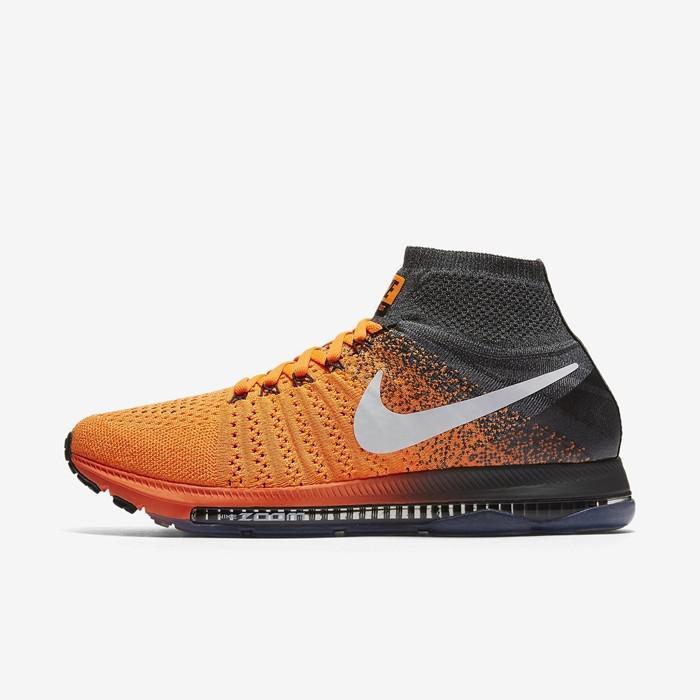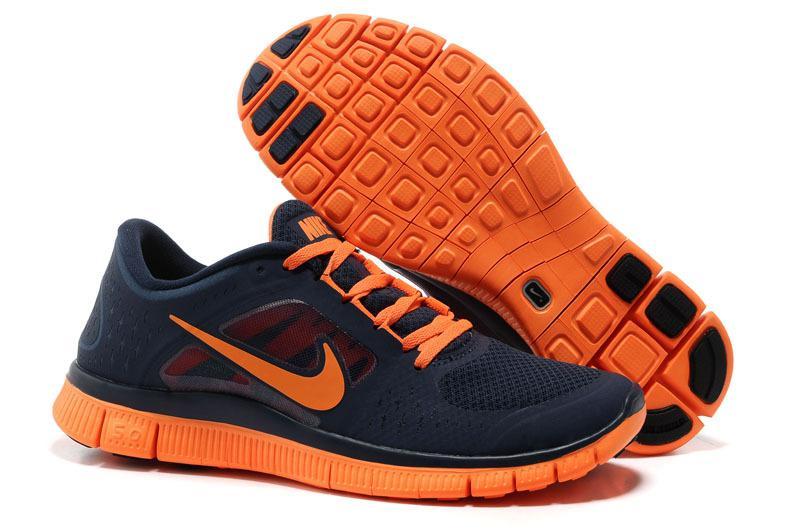The first image is the image on the left, the second image is the image on the right. Examine the images to the left and right. Is the description "One image shows a pair of sneakers, with one shoe posed with the sole facing the camera and the other shoe pointed rightward, and the other image shows a single sneaker turned leftward." accurate? Answer yes or no. Yes. The first image is the image on the left, the second image is the image on the right. Given the left and right images, does the statement "The right image contains no more than one shoe." hold true? Answer yes or no. No. 